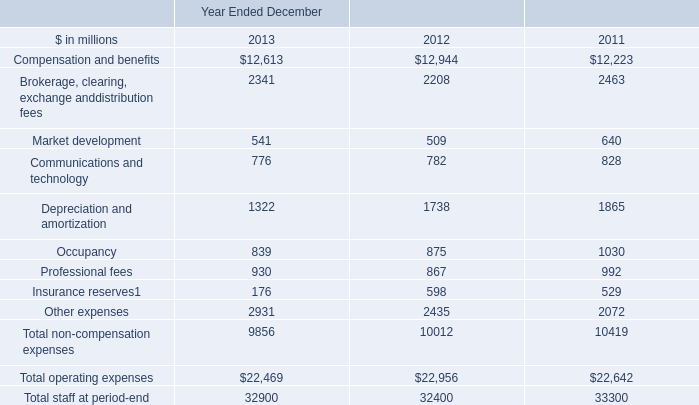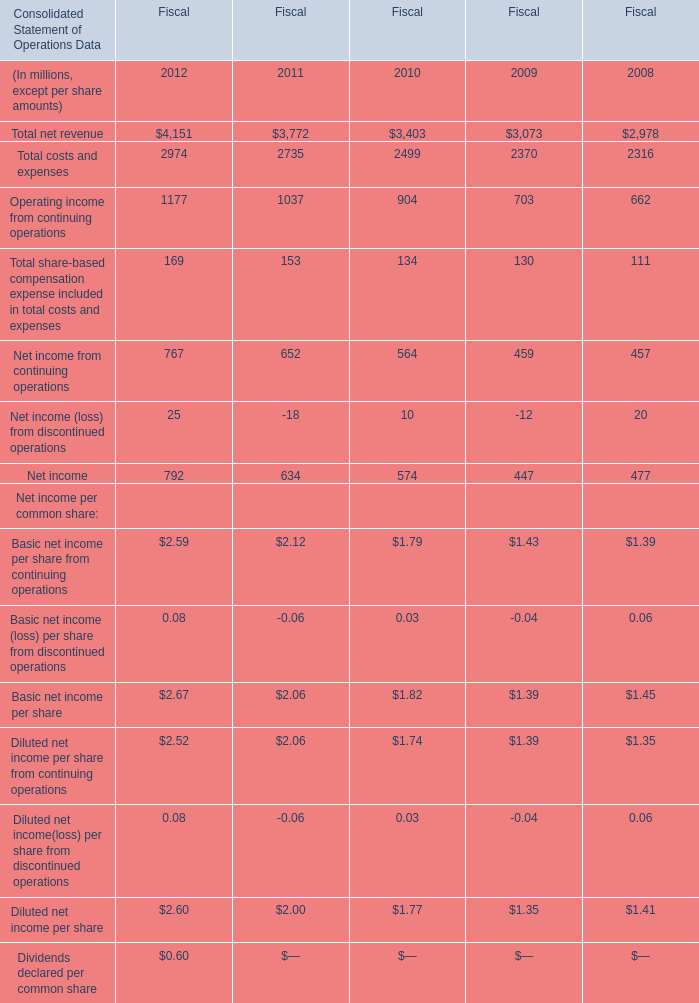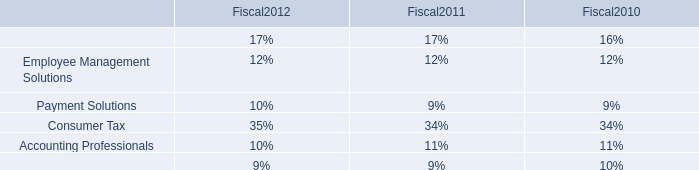What is the average growth rate of Total net revenue between 2011 and 2012? (in %) 
Computations: ((((3772 - 3403) / 3403) + ((4151 - 3772) / 3772)) / 2)
Answer: 0.10446. 